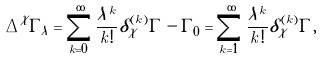Convert formula to latex. <formula><loc_0><loc_0><loc_500><loc_500>\Delta ^ { \mathcal { X } } \varGamma _ { \lambda } = \sum _ { k = 0 } ^ { \infty } \frac { \lambda ^ { k } } { k ! } \delta ^ { ( k ) } _ { \mathcal { X } } \varGamma - \varGamma _ { 0 } = \sum _ { k = 1 } ^ { \infty } \frac { \lambda ^ { k } } { k ! } \delta ^ { ( k ) } _ { \mathcal { X } } \varGamma ,</formula> 